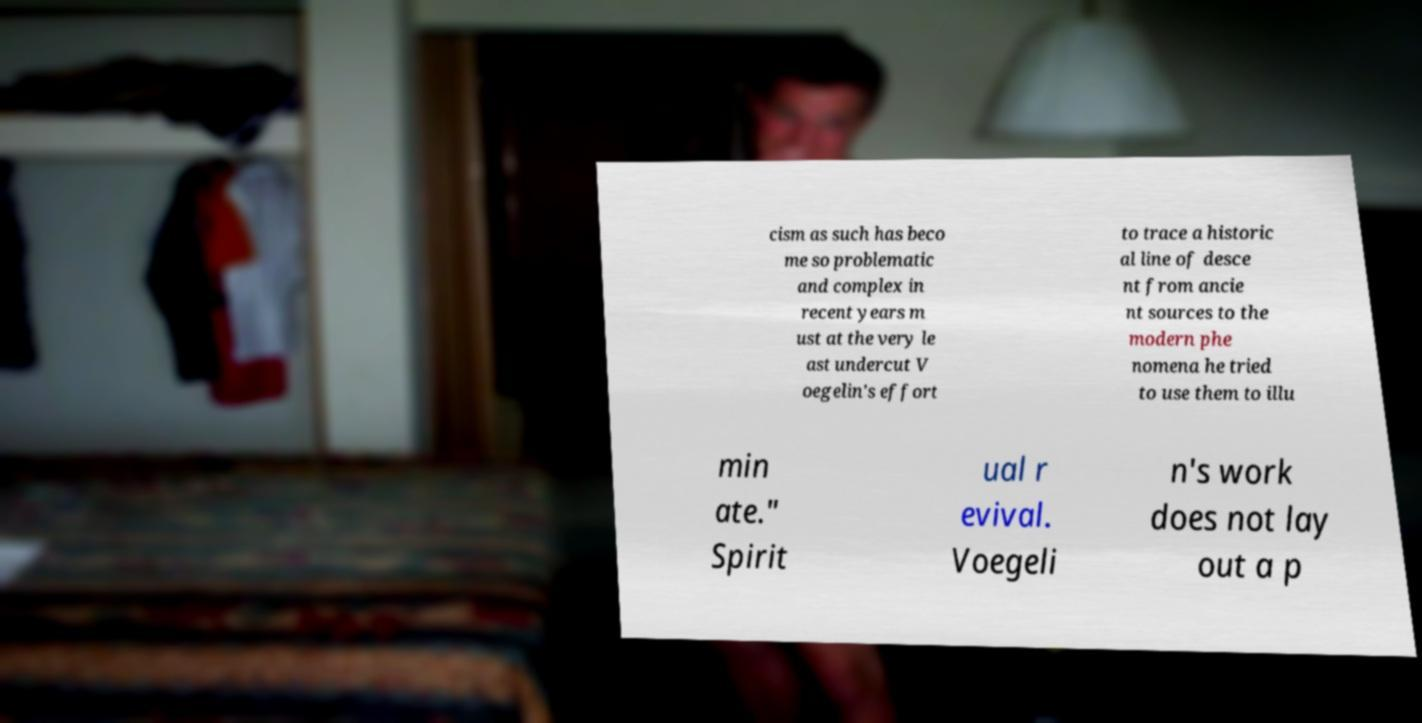Please identify and transcribe the text found in this image. cism as such has beco me so problematic and complex in recent years m ust at the very le ast undercut V oegelin's effort to trace a historic al line of desce nt from ancie nt sources to the modern phe nomena he tried to use them to illu min ate." Spirit ual r evival. Voegeli n's work does not lay out a p 